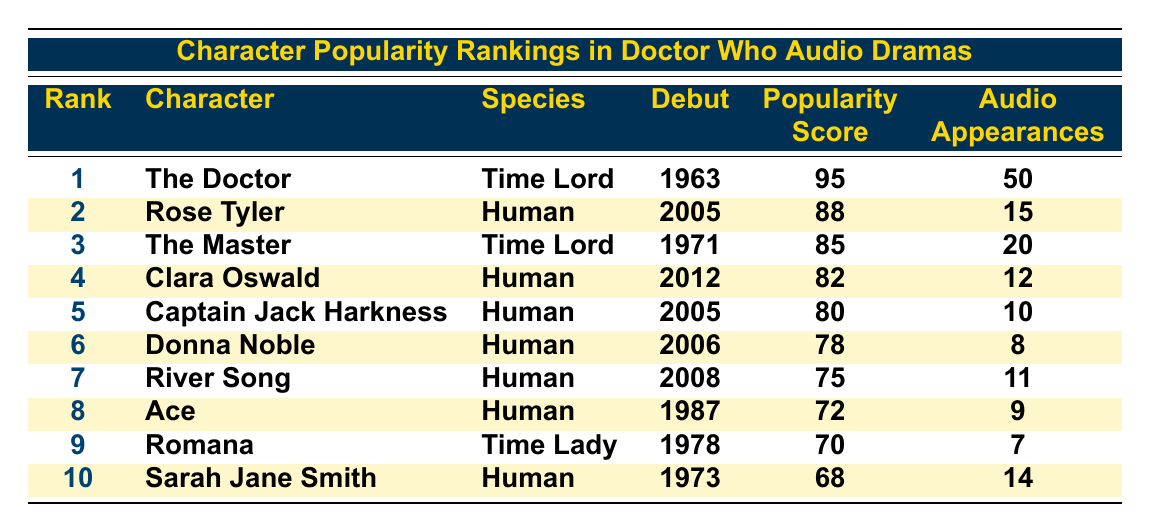What is the popularity score of "The Doctor"? The popularity score for "The Doctor" is found in the fourth column of the first row, which is 95.
Answer: 95 How many audio drama appearances does "Rose Tyler" have? The number of audio drama appearances for "Rose Tyler" is in the sixth column of the second row, which is 15.
Answer: 15 Which character has the highest popularity score? The character with the highest popularity score can be determined by comparing the scores in the fifth column, where "The Doctor" has a score of 95, which is the highest.
Answer: The Doctor Is "Clara Oswald" more popular than "River Song"? To determine this, we compare their popularity scores: Clara Oswald has a score of 82, while River Song has a score of 75. Since 82 is greater than 75, Clara Oswald is indeed more popular.
Answer: Yes What is the total number of audio drama appearances for the top three characters? The total appearances for the top three characters can be calculated by adding their appearances: 50 (The Doctor) + 15 (Rose Tyler) + 20 (The Master) = 85.
Answer: 85 Which species has more characters in the top 10, Human or Time Lord? The top 10 list contains 7 Human characters (Rose Tyler, Clara Oswald, Captain Jack Harkness, Donna Noble, River Song, Ace, and Sarah Jane Smith) and 3 Time Lords (The Doctor, The Master, and Romana). Since 7 is greater than 3, Humans have more characters.
Answer: Human What is the average popularity score of all characters listed? To find the average, we first sum the popularity scores: 95 + 88 + 85 + 82 + 80 + 78 + 75 + 72 + 70 + 68 = 818. There are 10 characters, so we divide 818 by 10, resulting in an average of 81.8.
Answer: 81.8 Who is the least popular character based on the table? The least popular character can be found by checking the popularity scores, where Sarah Jane Smith has the lowest score of 68, indicating she is the least popular in this list.
Answer: Sarah Jane Smith How many more audio drama appearances does "The Master" have than "Ace"? The number of appearances for "The Master" is 20 and for "Ace" is 9. By calculating the difference: 20 - 9 = 11, we find that "The Master" has 11 more appearances than "Ace".
Answer: 11 Which character debuted first among those listed? The debut years are compared: The Doctor (1963), Rose Tyler (2005), The Master (1971), Clara Oswald (2012), and others. "The Doctor" has the earliest debut year of 1963.
Answer: The Doctor 